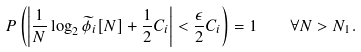Convert formula to latex. <formula><loc_0><loc_0><loc_500><loc_500>P \left ( \left | \frac { 1 } { N } \log _ { 2 } \widetilde { \phi } _ { i } [ N ] + \frac { 1 } { 2 } C _ { i } \right | < \frac { \epsilon } { 2 } C _ { i } \right ) = 1 \quad \forall N > N _ { 1 } .</formula> 